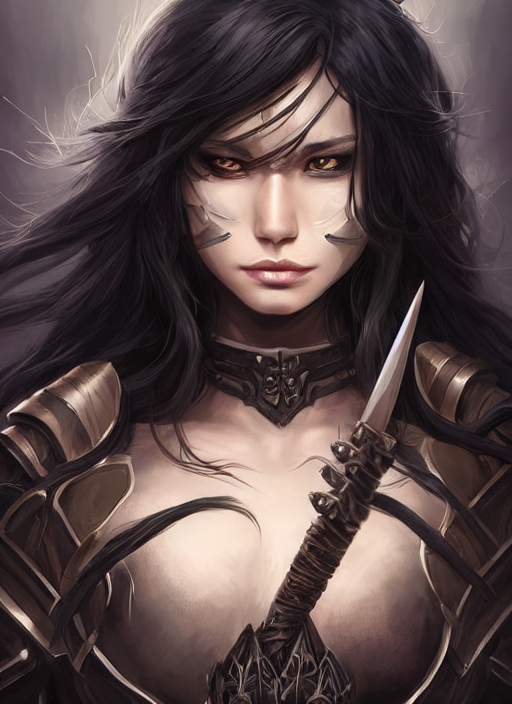What kind of atmosphere or mood does the character's expression convey? The character's expression conveys a sense of resolute determination and a touch of mysterious allure. The eyes seem to be focused and calculating, perhaps indicative of strategic thinking or anticipation before a battle. 